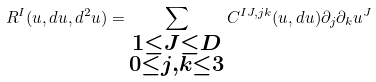<formula> <loc_0><loc_0><loc_500><loc_500>R ^ { I } ( u , d u , d ^ { 2 } u ) = \sum _ { \substack { 1 \leq J \leq D \\ 0 \leq j , k \leq 3 } } C ^ { I J , j k } ( u , d u ) \partial _ { j } \partial _ { k } u ^ { J }</formula> 